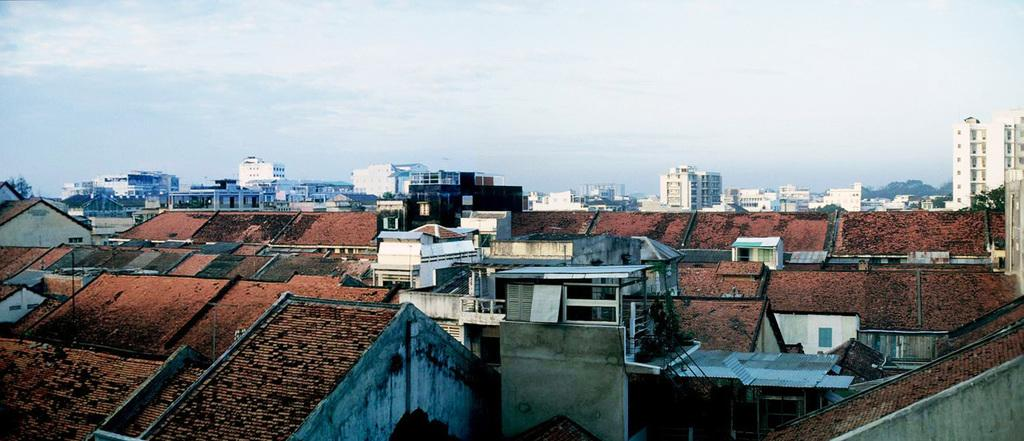What type of structures are present in the image? There are buildings in the image. Can you describe the colors of the buildings? The buildings have various colors, including brown, white, cream, and black. What can be seen in the background of the image? There are trees in the background of the image. What is the color of the trees? The trees are green. What is visible above the buildings and trees? The sky is visible in the image. What colors can be seen in the sky? The sky has blue and white colors. What type of curtain is hanging from the moon in the image? There is no moon or curtain present in the image. What sense is being evoked by the image? The image does not evoke a specific sense, as it is a visual representation of buildings, trees, and the sky. 